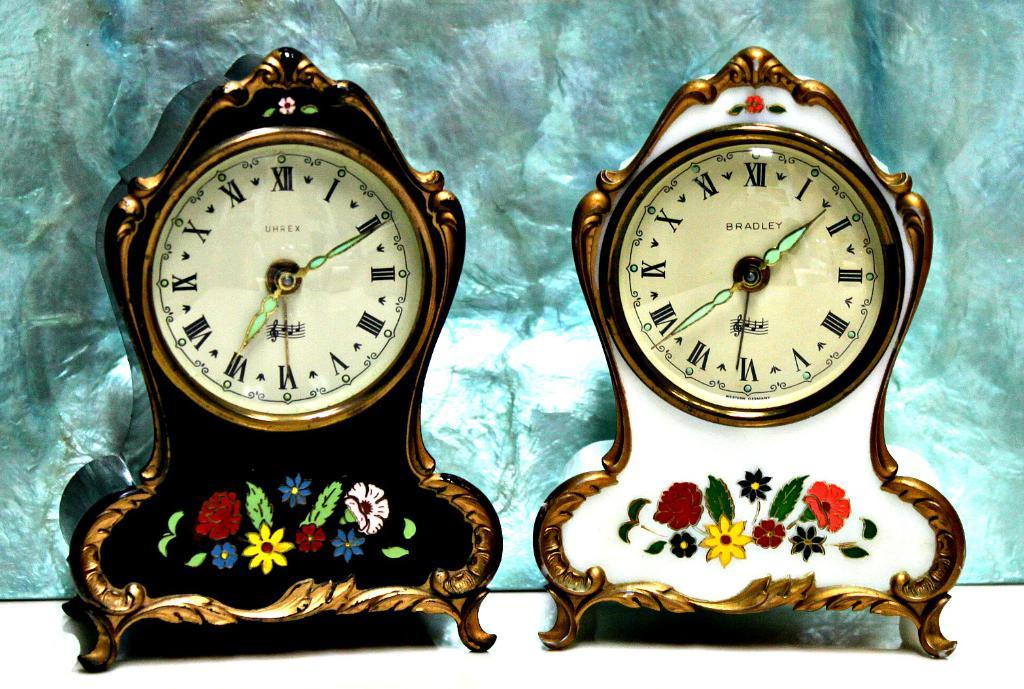<image>
Give a short and clear explanation of the subsequent image. A Bradley clock on the right has the time as 1:27. 